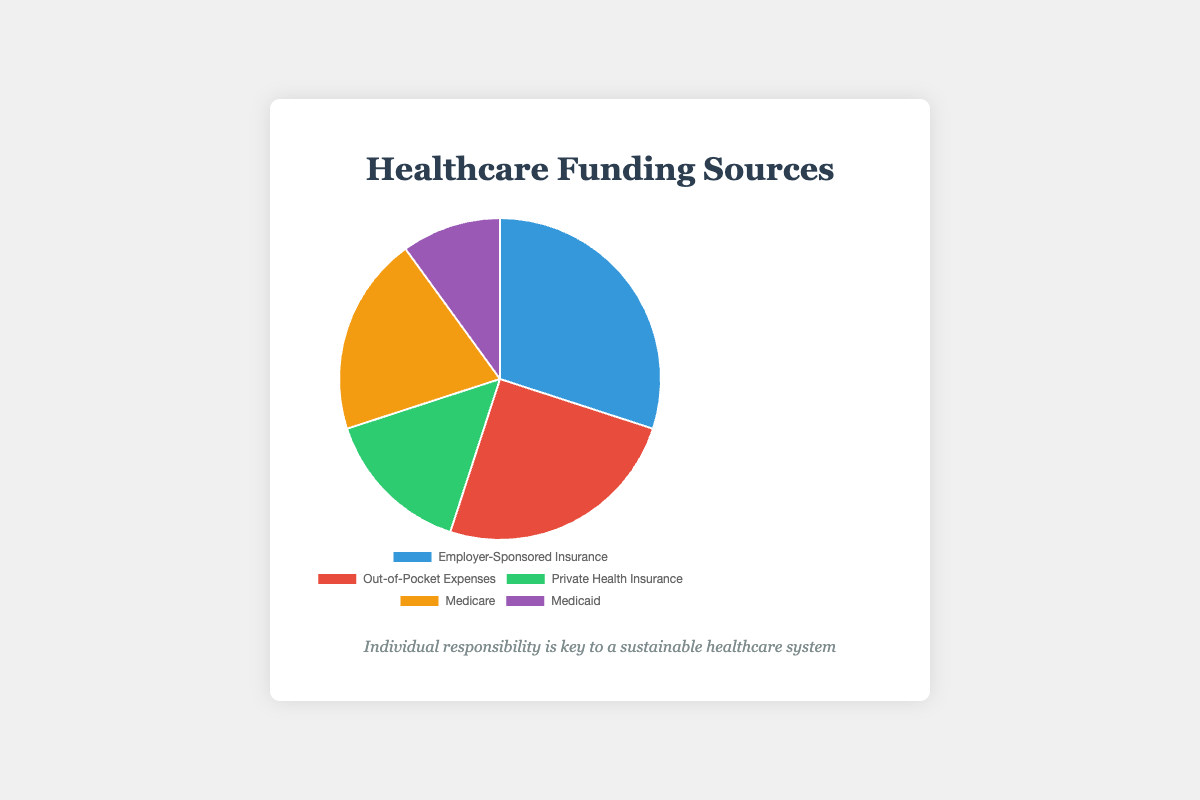Which funding source has the highest percentage? The slice representing "Employer-Sponsored Insurance" is the largest, indicating that it has the highest percentage.
Answer: Employer-Sponsored Insurance Which funding source has the lowest percentage? The slice representing "Medicaid" is the smallest, indicating that it has the lowest percentage.
Answer: Medicaid What is the combined percentage of all private contributions (Employer-Sponsored Insurance, Out-of-Pocket Expenses, Private Health Insurance)? Sum the percentages of "Employer-Sponsored Insurance" (30%), "Out-of-Pocket Expenses" (25%), and "Private Health Insurance" (15%). The combined percentage is 30% + 25% + 15% = 70%.
Answer: 70% How does the percentage of Medicare compare to that of Medicaid? Medicare has a larger slice than Medicaid. Specifically, Medicare accounts for 20% while Medicaid accounts for 10%. Thus, Medicare's percentage is double that of Medicaid's.
Answer: Medicare is double Medicaid Are the private insurance contributions greater than the public insurance contributions (Medicare and Medicaid combined)? Sum the percentages of "Medicare" (20%) and "Medicaid" (10%) to get public contributions which is 30%. Compare this with the percentages of the private insurances: "Private Health Insurance" (15%). Private insurance contributions are 15%, which is less than the 30% from public contributions.
Answer: No Which funding sources are represented by green and purple colors in the pie chart? The "Private Health Insurance" slice is green and the "Medicaid" slice is purple.
Answer: Private Health Insurance and Medicaid If the percentages of Out-of-Pocket Expenses and Medicare were swapped, which would now have a higher percentage? If we swap the percentages of "Out-of-Pocket Expenses" (25%) and "Medicare" (20%), then "Medicare" would have 25% and "Out-of-Pocket Expenses" would have 20%. Therefore, "Medicare" would now have the higher percentage.
Answer: Medicare What is the average percentage of all funding sources? Sum all the percentages: 30% (Employer-Sponsored Insurance) + 25% (Out-of-Pocket Expenses) + 15% (Private Health Insurance) + 20% (Medicare) + 10% (Medicaid) = 100%. Divide by the number of sources (5). The average is 100% / 5 = 20%.
Answer: 20% How much more percentage does Employer-Sponsored Insurance have compared to Private Health Insurance? Subtract the percentage of "Private Health Insurance" (15%) from "Employer-Sponsored Insurance" (30%). The difference is 30% - 15% = 15%.
Answer: 15% What is the total percentage of public assistance (Medicare and Medicaid combined)? Sum the percentages of "Medicare" (20%) and "Medicaid" (10%). The total is 20% + 10% = 30%.
Answer: 30% 